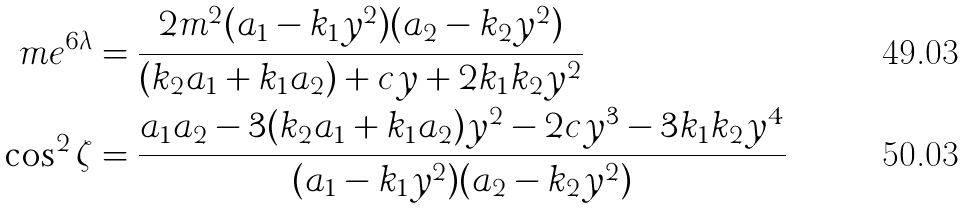<formula> <loc_0><loc_0><loc_500><loc_500>\ m e ^ { 6 \lambda } & = \frac { 2 m ^ { 2 } ( a _ { 1 } - k _ { 1 } y ^ { 2 } ) ( a _ { 2 } - k _ { 2 } y ^ { 2 } ) } { ( k _ { 2 } a _ { 1 } + k _ { 1 } a _ { 2 } ) + c y + 2 k _ { 1 } k _ { 2 } y ^ { 2 } } \\ \cos ^ { 2 } \zeta & = \frac { a _ { 1 } a _ { 2 } - 3 ( k _ { 2 } a _ { 1 } + k _ { 1 } a _ { 2 } ) y ^ { 2 } - 2 c y ^ { 3 } - 3 k _ { 1 } k _ { 2 } y ^ { 4 } } { ( a _ { 1 } - k _ { 1 } y ^ { 2 } ) ( a _ { 2 } - k _ { 2 } y ^ { 2 } ) }</formula> 